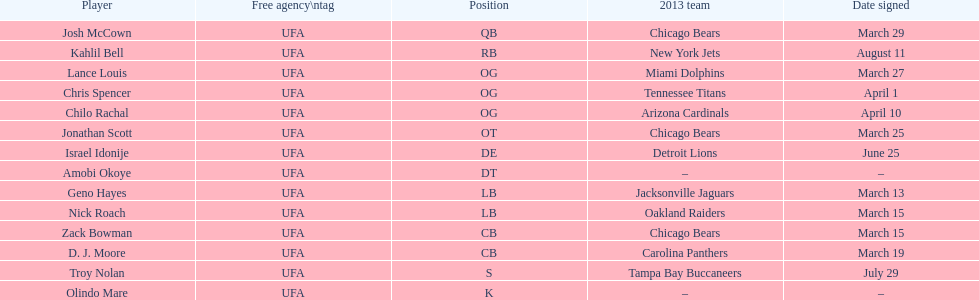Would you mind parsing the complete table? {'header': ['Player', 'Free agency\\ntag', 'Position', '2013 team', 'Date signed'], 'rows': [['Josh McCown', 'UFA', 'QB', 'Chicago Bears', 'March 29'], ['Kahlil Bell', 'UFA', 'RB', 'New York Jets', 'August 11'], ['Lance Louis', 'UFA', 'OG', 'Miami Dolphins', 'March 27'], ['Chris Spencer', 'UFA', 'OG', 'Tennessee Titans', 'April 1'], ['Chilo Rachal', 'UFA', 'OG', 'Arizona Cardinals', 'April 10'], ['Jonathan Scott', 'UFA', 'OT', 'Chicago Bears', 'March 25'], ['Israel Idonije', 'UFA', 'DE', 'Detroit Lions', 'June 25'], ['Amobi Okoye', 'UFA', 'DT', '–', '–'], ['Geno Hayes', 'UFA', 'LB', 'Jacksonville Jaguars', 'March 13'], ['Nick Roach', 'UFA', 'LB', 'Oakland Raiders', 'March 15'], ['Zack Bowman', 'UFA', 'CB', 'Chicago Bears', 'March 15'], ['D. J. Moore', 'UFA', 'CB', 'Carolina Panthers', 'March 19'], ['Troy Nolan', 'UFA', 'S', 'Tampa Bay Buccaneers', 'July 29'], ['Olindo Mare', 'UFA', 'K', '–', '–']]} What is the combined total of 2013 teams on the diagram? 10. 